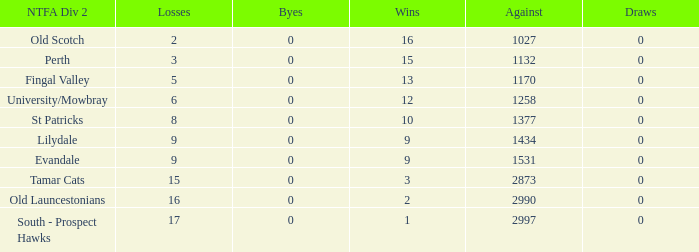What is the lowest number of draws of the team with 9 wins and less than 0 byes? None. 